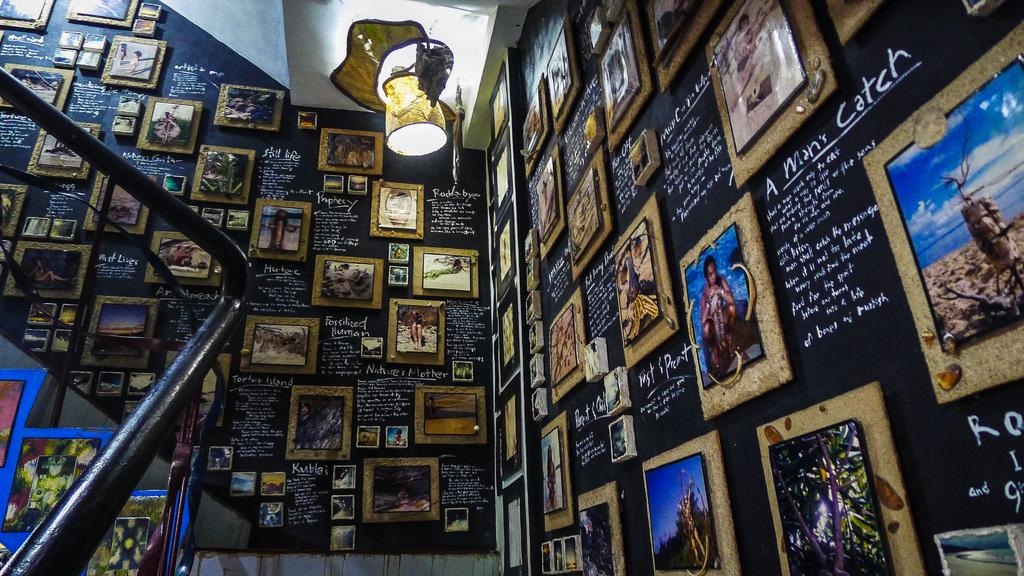What is attached to the wall in the image? There are frames attached to the wall in the image. What is written on the wall in the image? There is writing on the wall in the image. What can be seen in the background of the image? There is light, stairs, and poles visible in the background of the image. What flavor of sky is visible in the image? There is no sky visible in the image, and therefore no flavor can be determined. What type of tank is present in the image? There is no tank present in the image. 